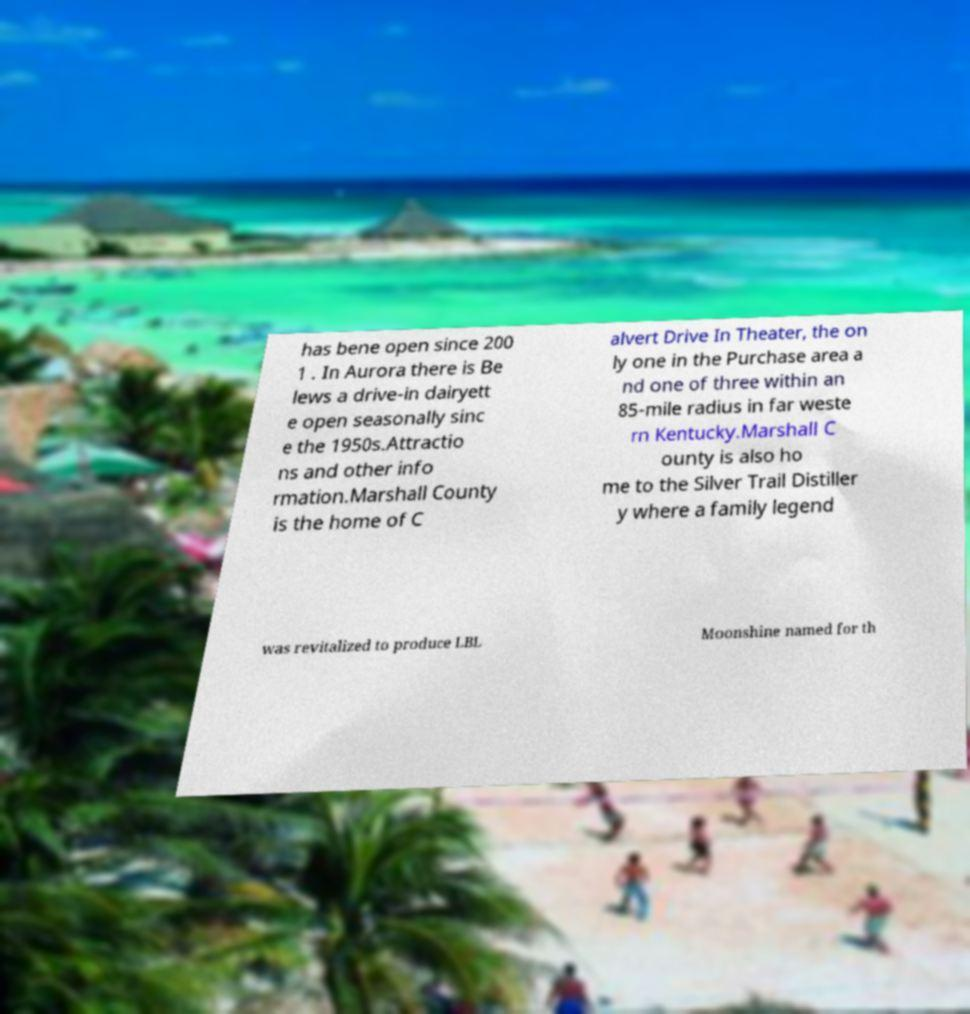Can you accurately transcribe the text from the provided image for me? has bene open since 200 1 . In Aurora there is Be lews a drive-in dairyett e open seasonally sinc e the 1950s.Attractio ns and other info rmation.Marshall County is the home of C alvert Drive In Theater, the on ly one in the Purchase area a nd one of three within an 85-mile radius in far weste rn Kentucky.Marshall C ounty is also ho me to the Silver Trail Distiller y where a family legend was revitalized to produce LBL Moonshine named for th 